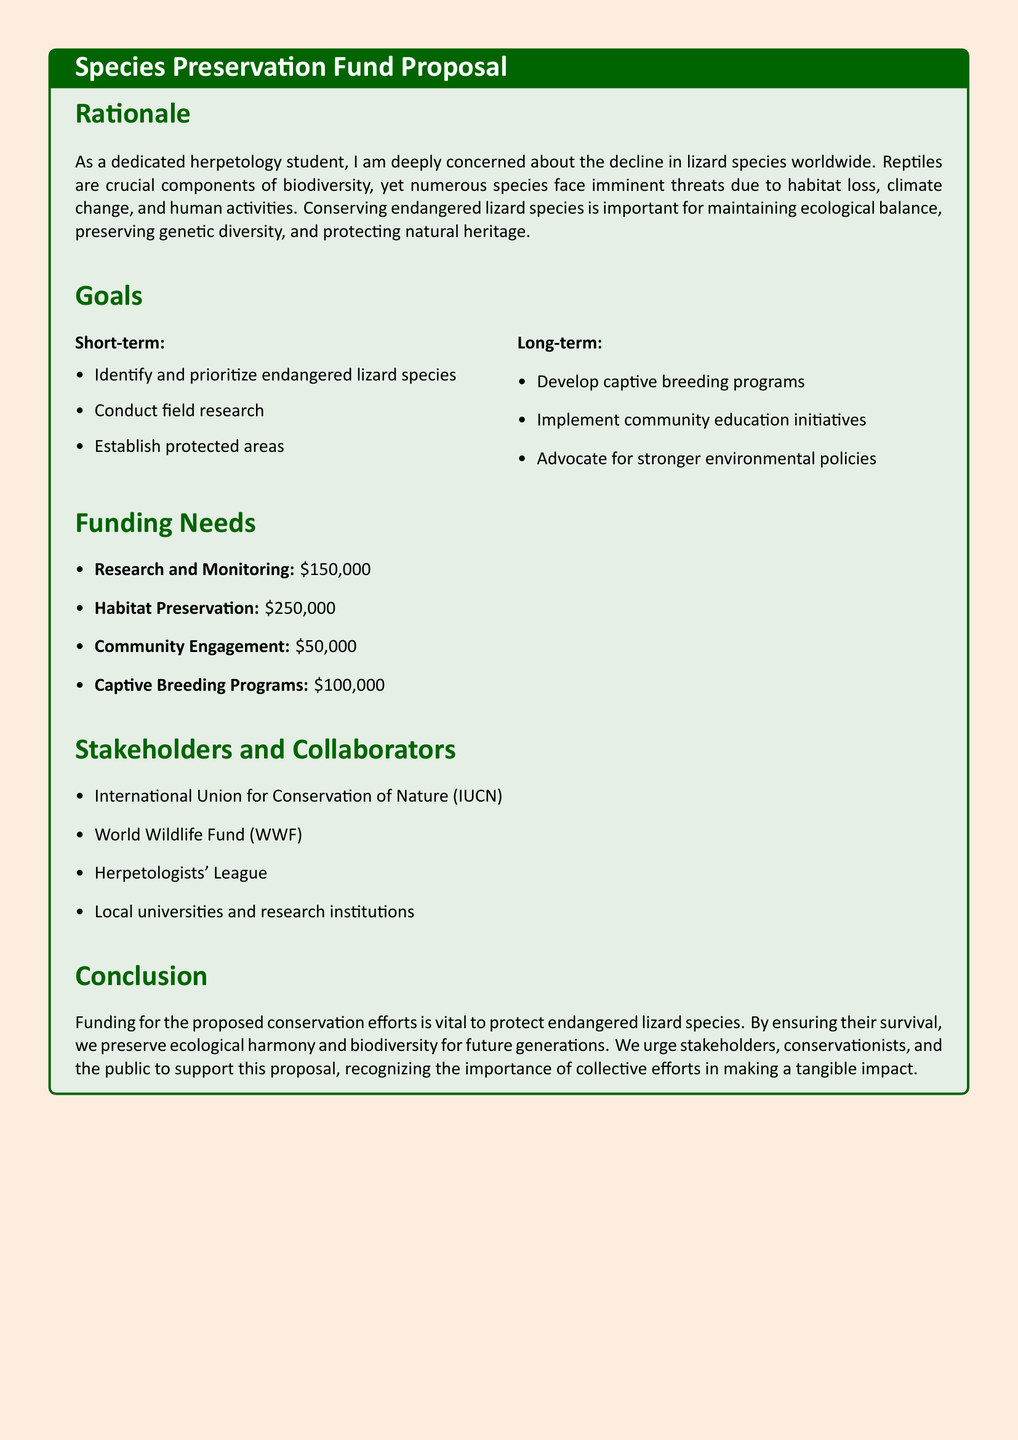What is the total funding needed for habitat preservation? The document states that habitat preservation requires $250,000.
Answer: $250,000 What is the first short-term goal listed? The first short-term goal in the document is to identify and prioritize endangered lizard species.
Answer: Identify and prioritize endangered lizard species Which organization is mentioned as a stakeholder? The document lists the International Union for Conservation of Nature (IUCN) as one of the stakeholders.
Answer: International Union for Conservation of Nature (IUCN) How much funding is allocated for community engagement? The document specifies that $50,000 is needed for community engagement.
Answer: $50,000 What is the main reason for conserving endangered lizard species? The rationale in the document outlines that conserving endangered lizard species is important for maintaining ecological balance.
Answer: Maintaining ecological balance What are the long-term goals focused on? The long-term goals mentioned include developing captive breeding programs, implementing community education initiatives, and advocating for stronger environmental policies.
Answer: Developing captive breeding programs, implementing community education initiatives, and advocating for stronger environmental policies What is the total funding needed for research and monitoring? According to the document, the total funding required for research and monitoring is $150,000.
Answer: $150,000 What is the color theme used in the document? The document uses a color theme of lizard green for its title backgrounds and sections.
Answer: Lizard green 